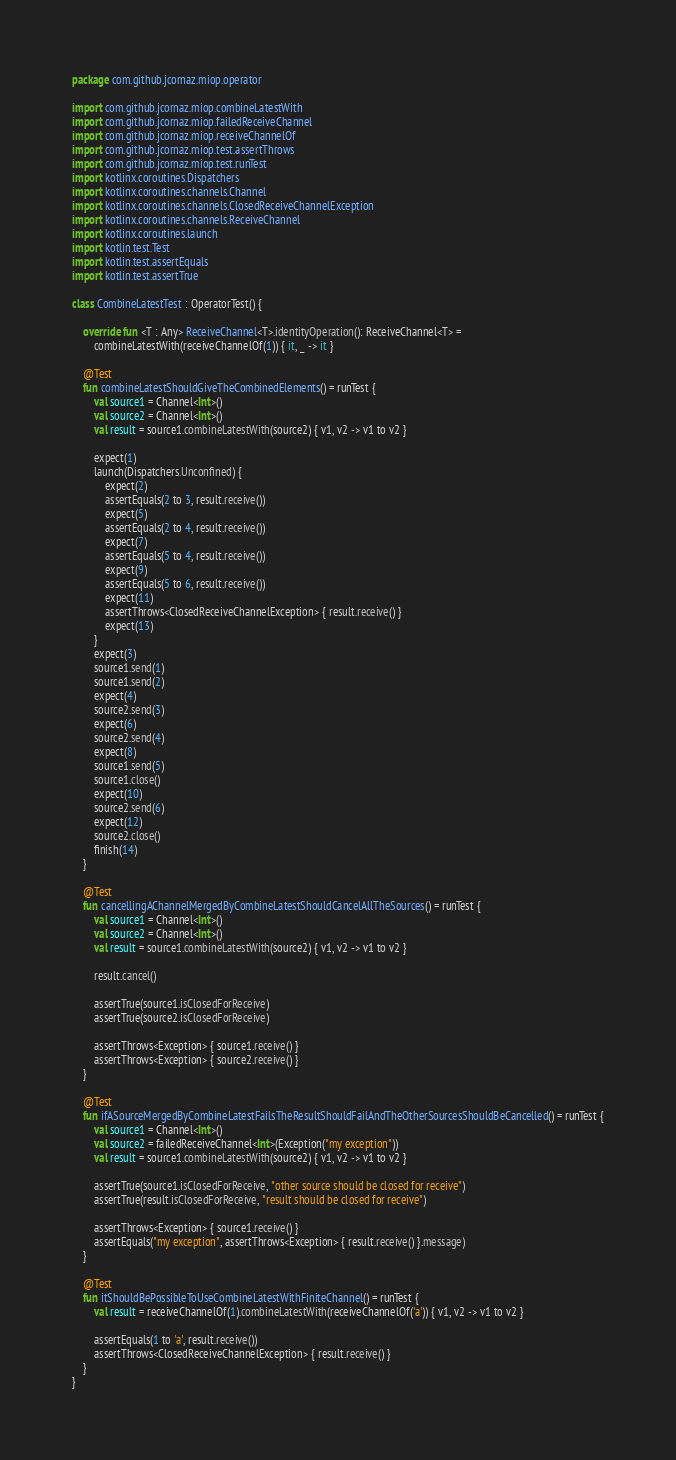Convert code to text. <code><loc_0><loc_0><loc_500><loc_500><_Kotlin_>package com.github.jcornaz.miop.operator

import com.github.jcornaz.miop.combineLatestWith
import com.github.jcornaz.miop.failedReceiveChannel
import com.github.jcornaz.miop.receiveChannelOf
import com.github.jcornaz.miop.test.assertThrows
import com.github.jcornaz.miop.test.runTest
import kotlinx.coroutines.Dispatchers
import kotlinx.coroutines.channels.Channel
import kotlinx.coroutines.channels.ClosedReceiveChannelException
import kotlinx.coroutines.channels.ReceiveChannel
import kotlinx.coroutines.launch
import kotlin.test.Test
import kotlin.test.assertEquals
import kotlin.test.assertTrue

class CombineLatestTest : OperatorTest() {

    override fun <T : Any> ReceiveChannel<T>.identityOperation(): ReceiveChannel<T> =
        combineLatestWith(receiveChannelOf(1)) { it, _ -> it }

    @Test
    fun combineLatestShouldGiveTheCombinedElements() = runTest {
        val source1 = Channel<Int>()
        val source2 = Channel<Int>()
        val result = source1.combineLatestWith(source2) { v1, v2 -> v1 to v2 }

        expect(1)
        launch(Dispatchers.Unconfined) {
            expect(2)
            assertEquals(2 to 3, result.receive())
            expect(5)
            assertEquals(2 to 4, result.receive())
            expect(7)
            assertEquals(5 to 4, result.receive())
            expect(9)
            assertEquals(5 to 6, result.receive())
            expect(11)
            assertThrows<ClosedReceiveChannelException> { result.receive() }
            expect(13)
        }
        expect(3)
        source1.send(1)
        source1.send(2)
        expect(4)
        source2.send(3)
        expect(6)
        source2.send(4)
        expect(8)
        source1.send(5)
        source1.close()
        expect(10)
        source2.send(6)
        expect(12)
        source2.close()
        finish(14)
    }

    @Test
    fun cancellingAChannelMergedByCombineLatestShouldCancelAllTheSources() = runTest {
        val source1 = Channel<Int>()
        val source2 = Channel<Int>()
        val result = source1.combineLatestWith(source2) { v1, v2 -> v1 to v2 }

        result.cancel()

        assertTrue(source1.isClosedForReceive)
        assertTrue(source2.isClosedForReceive)

        assertThrows<Exception> { source1.receive() }
        assertThrows<Exception> { source2.receive() }
    }

    @Test
    fun ifASourceMergedByCombineLatestFailsTheResultShouldFailAndTheOtherSourcesShouldBeCancelled() = runTest {
        val source1 = Channel<Int>()
        val source2 = failedReceiveChannel<Int>(Exception("my exception"))
        val result = source1.combineLatestWith(source2) { v1, v2 -> v1 to v2 }

        assertTrue(source1.isClosedForReceive, "other source should be closed for receive")
        assertTrue(result.isClosedForReceive, "result should be closed for receive")

        assertThrows<Exception> { source1.receive() }
        assertEquals("my exception", assertThrows<Exception> { result.receive() }.message)
    }

    @Test
    fun itShouldBePossibleToUseCombineLatestWithFiniteChannel() = runTest {
        val result = receiveChannelOf(1).combineLatestWith(receiveChannelOf('a')) { v1, v2 -> v1 to v2 }

        assertEquals(1 to 'a', result.receive())
        assertThrows<ClosedReceiveChannelException> { result.receive() }
    }
}</code> 